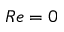Convert formula to latex. <formula><loc_0><loc_0><loc_500><loc_500>R e = 0</formula> 